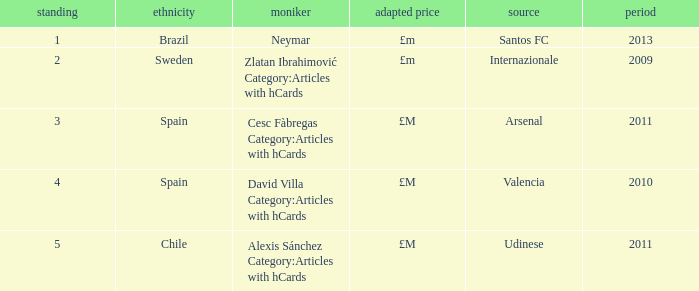What is the most recent year a player was from Valencia? 2010.0. 